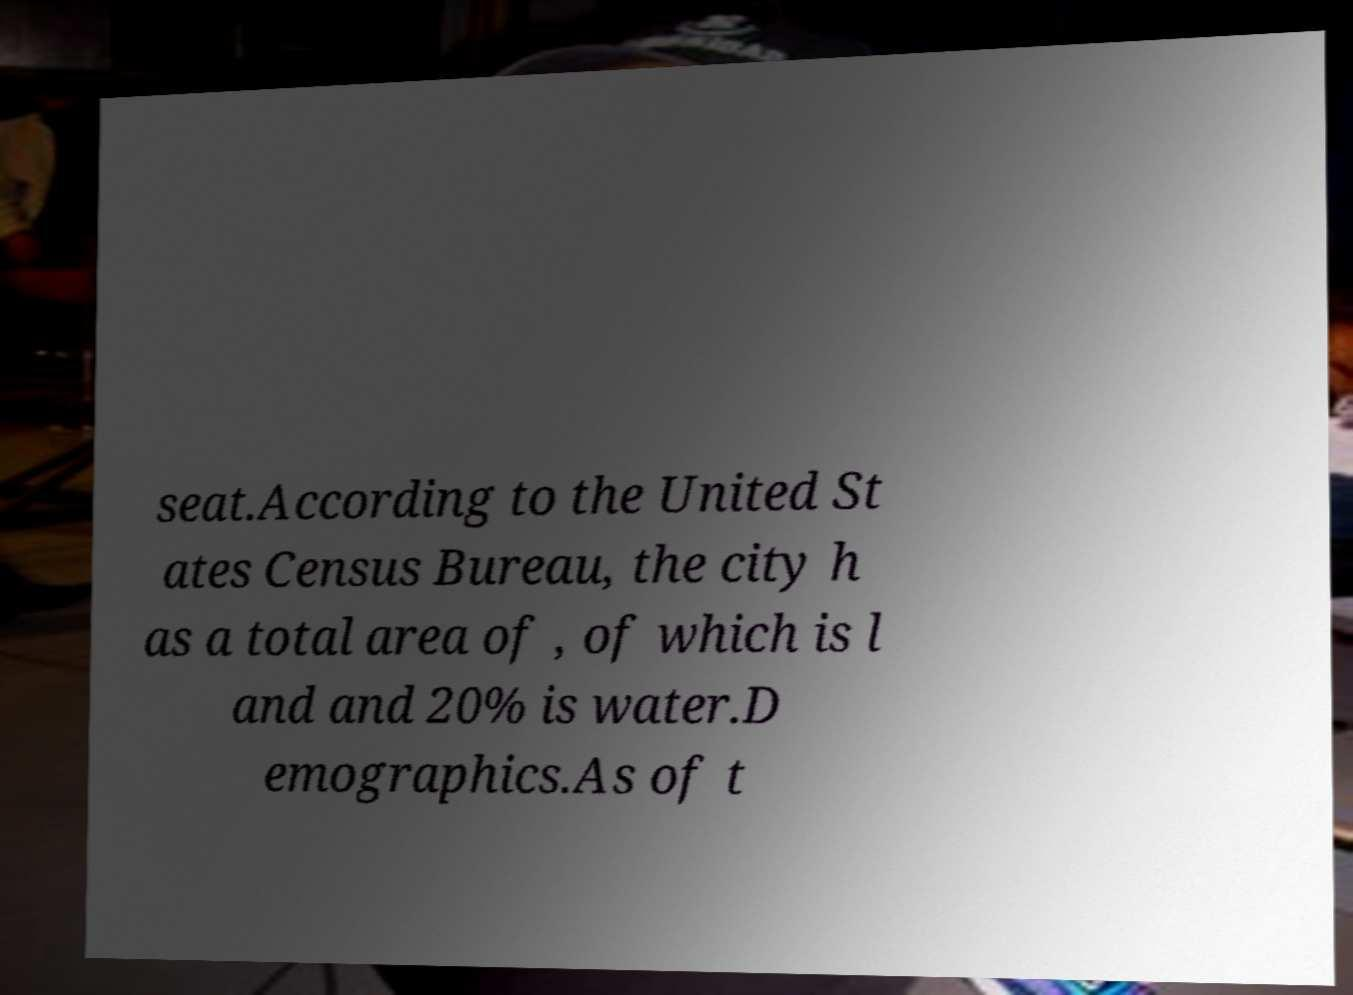For documentation purposes, I need the text within this image transcribed. Could you provide that? seat.According to the United St ates Census Bureau, the city h as a total area of , of which is l and and 20% is water.D emographics.As of t 